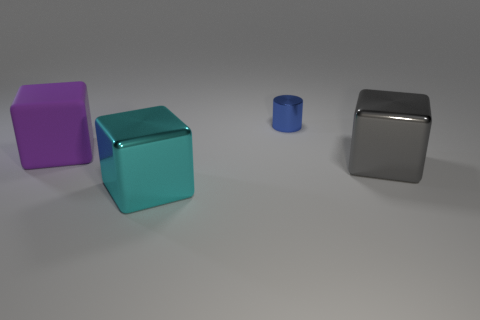Are there any other things that are the same size as the metallic cylinder?
Your response must be concise. No. Is there any other thing that is the same material as the big purple block?
Make the answer very short. No. There is a object that is behind the purple matte thing on the left side of the big metal object that is on the left side of the large gray metallic thing; what shape is it?
Your answer should be very brief. Cylinder. Is the number of metallic objects that are behind the cyan metallic object less than the number of things that are left of the gray shiny block?
Provide a short and direct response. Yes. There is a big metal thing on the right side of the small blue object; is it the same shape as the metal thing that is behind the large gray metallic object?
Provide a succinct answer. No. What shape is the blue thing behind the shiny object right of the small metallic thing?
Make the answer very short. Cylinder. Are there any purple objects that have the same material as the cylinder?
Make the answer very short. No. There is a cube that is to the left of the cyan metal block; what is it made of?
Give a very brief answer. Rubber. What is the purple block made of?
Make the answer very short. Rubber. Is the thing that is behind the large purple object made of the same material as the large gray object?
Provide a short and direct response. Yes. 